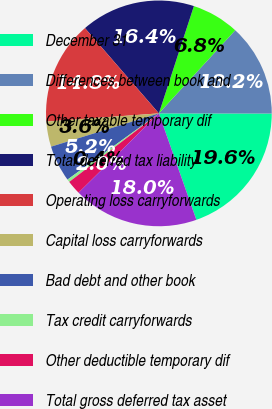Convert chart. <chart><loc_0><loc_0><loc_500><loc_500><pie_chart><fcel>December 31<fcel>Differences between book and<fcel>Other taxable temporary dif<fcel>Total deferred tax liability<fcel>Operating loss carryforwards<fcel>Capital loss carryforwards<fcel>Bad debt and other book<fcel>Tax credit carryforwards<fcel>Other deductible temporary dif<fcel>Total gross deferred tax asset<nl><fcel>19.59%<fcel>13.2%<fcel>6.8%<fcel>16.39%<fcel>14.79%<fcel>3.61%<fcel>5.21%<fcel>0.41%<fcel>2.01%<fcel>17.99%<nl></chart> 